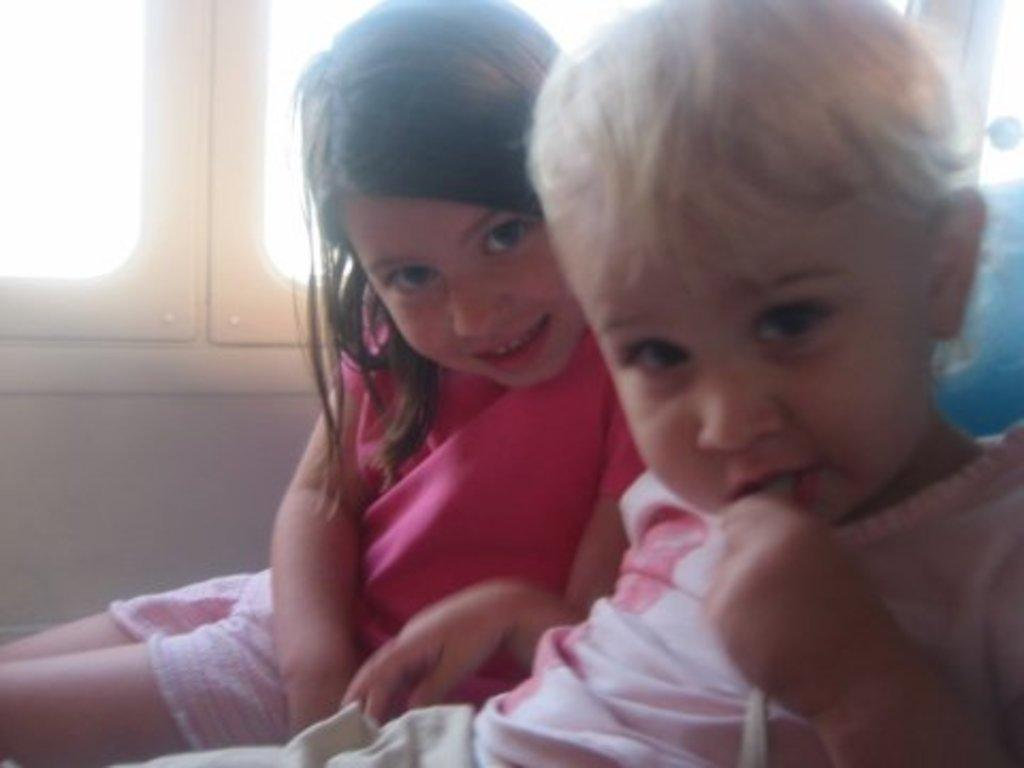How many children are present in the image? There are two children sitting in the image. What can be seen in the background of the image? There are windows visible in the background of the image. What type of desk is being used for the operation in the image? There is no desk or operation present in the image; it features two children sitting. Is there any smoke visible in the image? There is no smoke present in the image. 